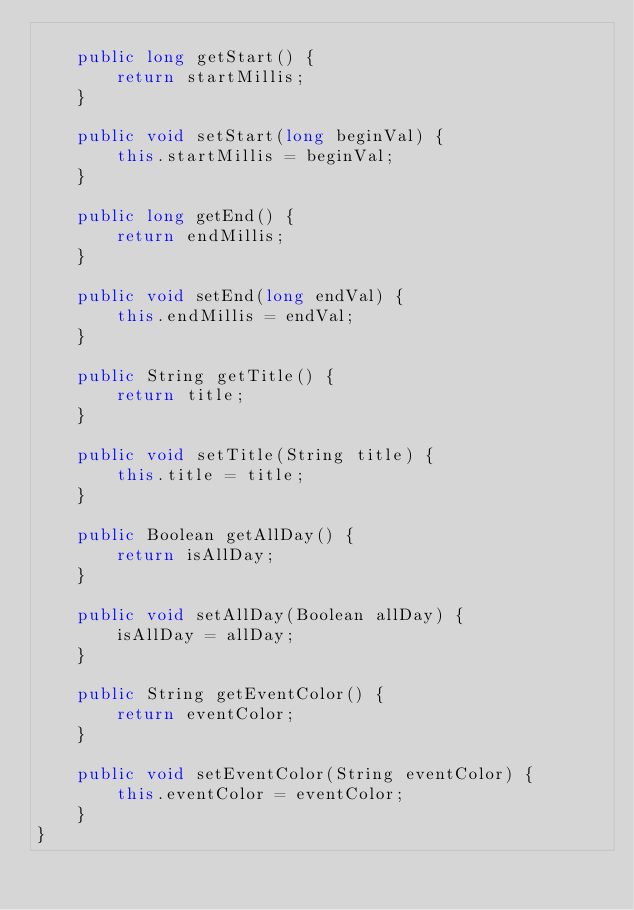Convert code to text. <code><loc_0><loc_0><loc_500><loc_500><_Java_>
    public long getStart() {
        return startMillis;
    }

    public void setStart(long beginVal) {
        this.startMillis = beginVal;
    }

    public long getEnd() {
        return endMillis;
    }

    public void setEnd(long endVal) {
        this.endMillis = endVal;
    }

    public String getTitle() {
        return title;
    }

    public void setTitle(String title) {
        this.title = title;
    }

    public Boolean getAllDay() {
        return isAllDay;
    }

    public void setAllDay(Boolean allDay) {
        isAllDay = allDay;
    }

    public String getEventColor() {
        return eventColor;
    }

    public void setEventColor(String eventColor) {
        this.eventColor = eventColor;
    }
}
</code> 